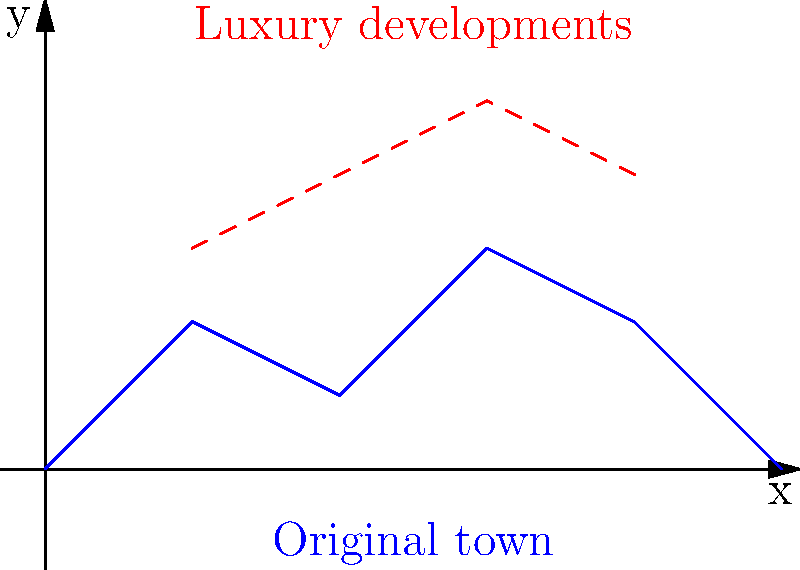Consider the topological surface representing a harbor town's landscape. The blue curve shows the original town profile, while the red dashed line represents proposed luxury developments. How does the genus of the surface change when the luxury developments are added, assuming the surface is closed by connecting the endpoints to form a closed loop? Let's approach this step-by-step:

1) First, let's consider the original town landscape (blue curve):
   - When we close this curve by connecting the endpoints, we get a simple closed loop.
   - A closed loop on a plane is topologically equivalent to a sphere.
   - The genus of a sphere is 0.

2) Now, let's look at the landscape with luxury developments (blue curve + red dashed line):
   - When we close this curve, we create a figure-eight shape.
   - A figure-eight shape, when considering it as a surface, is topologically equivalent to a torus (donut shape).
   - The genus of a torus is 1.

3) The genus of a surface is defined as the maximum number of cuts along non-intersecting closed simple curves without rendering the resultant manifold disconnected.
   - For the original landscape (sphere-like): No such cut exists, hence genus = 0.
   - For the landscape with developments (torus-like): One such cut exists, hence genus = 1.

4) Therefore, the change in genus is:
   $\Delta g = g_{new} - g_{original} = 1 - 0 = 1$

The genus increases by 1 when the luxury developments are added.
Answer: The genus increases by 1. 